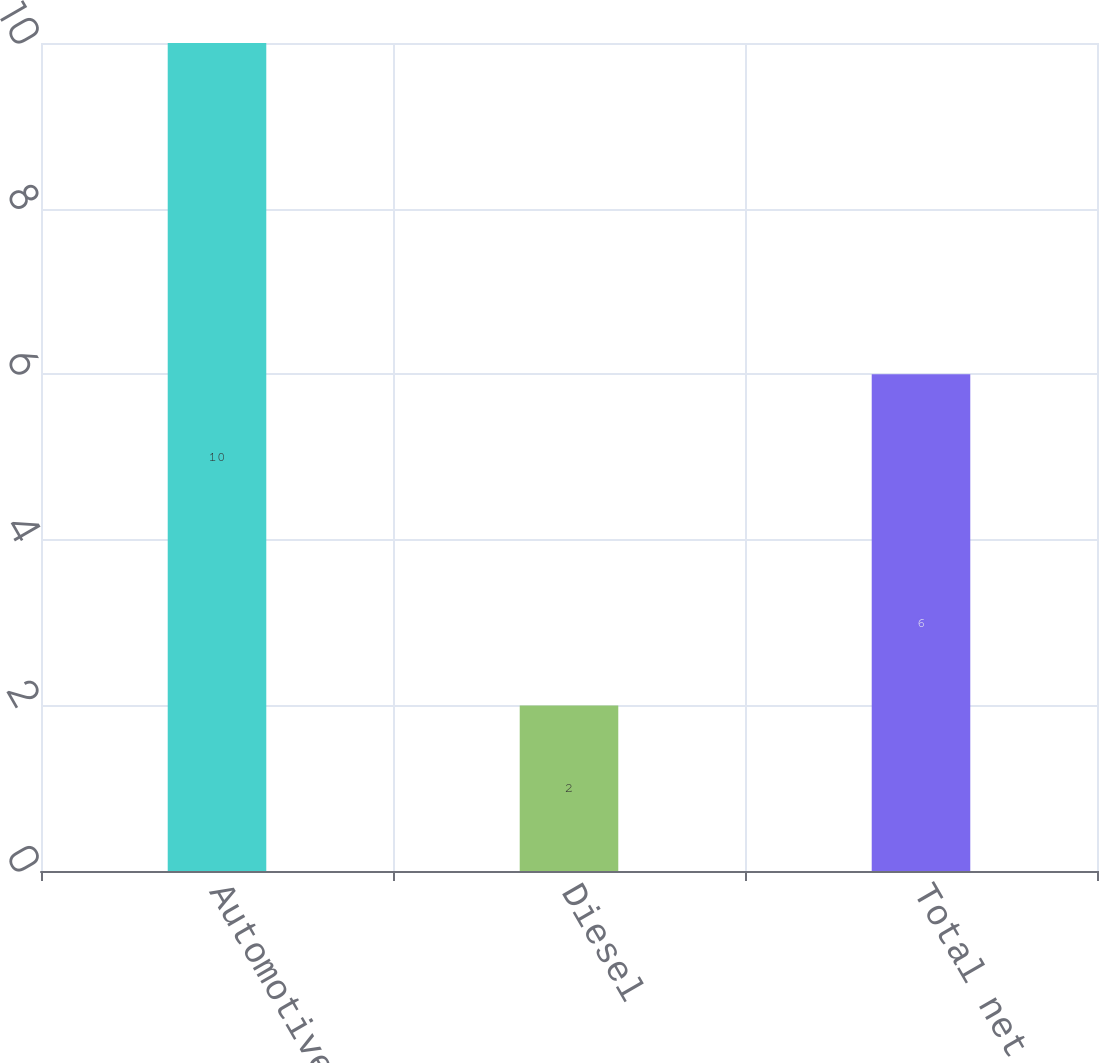<chart> <loc_0><loc_0><loc_500><loc_500><bar_chart><fcel>Automotive<fcel>Diesel<fcel>Total net sales<nl><fcel>10<fcel>2<fcel>6<nl></chart> 